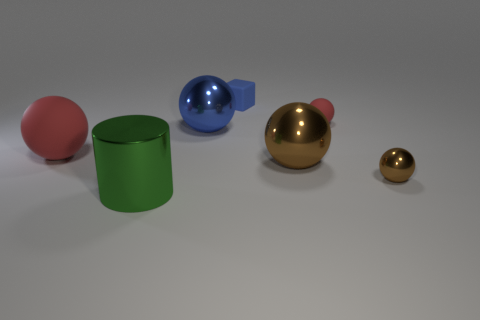Are there any large metallic objects that have the same color as the block?
Ensure brevity in your answer.  Yes. There is a large matte ball that is in front of the big blue object; what color is it?
Provide a short and direct response. Red. Is there any other thing that has the same shape as the green shiny object?
Ensure brevity in your answer.  No. What size is the red sphere that is right of the matte object that is in front of the tiny rubber sphere?
Offer a terse response. Small. Are there an equal number of big red rubber balls to the left of the large red ball and small red matte spheres that are right of the green metallic thing?
Make the answer very short. No. What is the color of the small object that is made of the same material as the small red ball?
Offer a very short reply. Blue. Is the small blue thing made of the same material as the tiny sphere to the right of the small red rubber thing?
Ensure brevity in your answer.  No. The rubber thing that is left of the large brown ball and to the right of the big red thing is what color?
Provide a succinct answer. Blue. How many cubes are either yellow rubber things or blue objects?
Give a very brief answer. 1. There is a large blue object; does it have the same shape as the tiny object in front of the big red matte sphere?
Offer a terse response. Yes. 